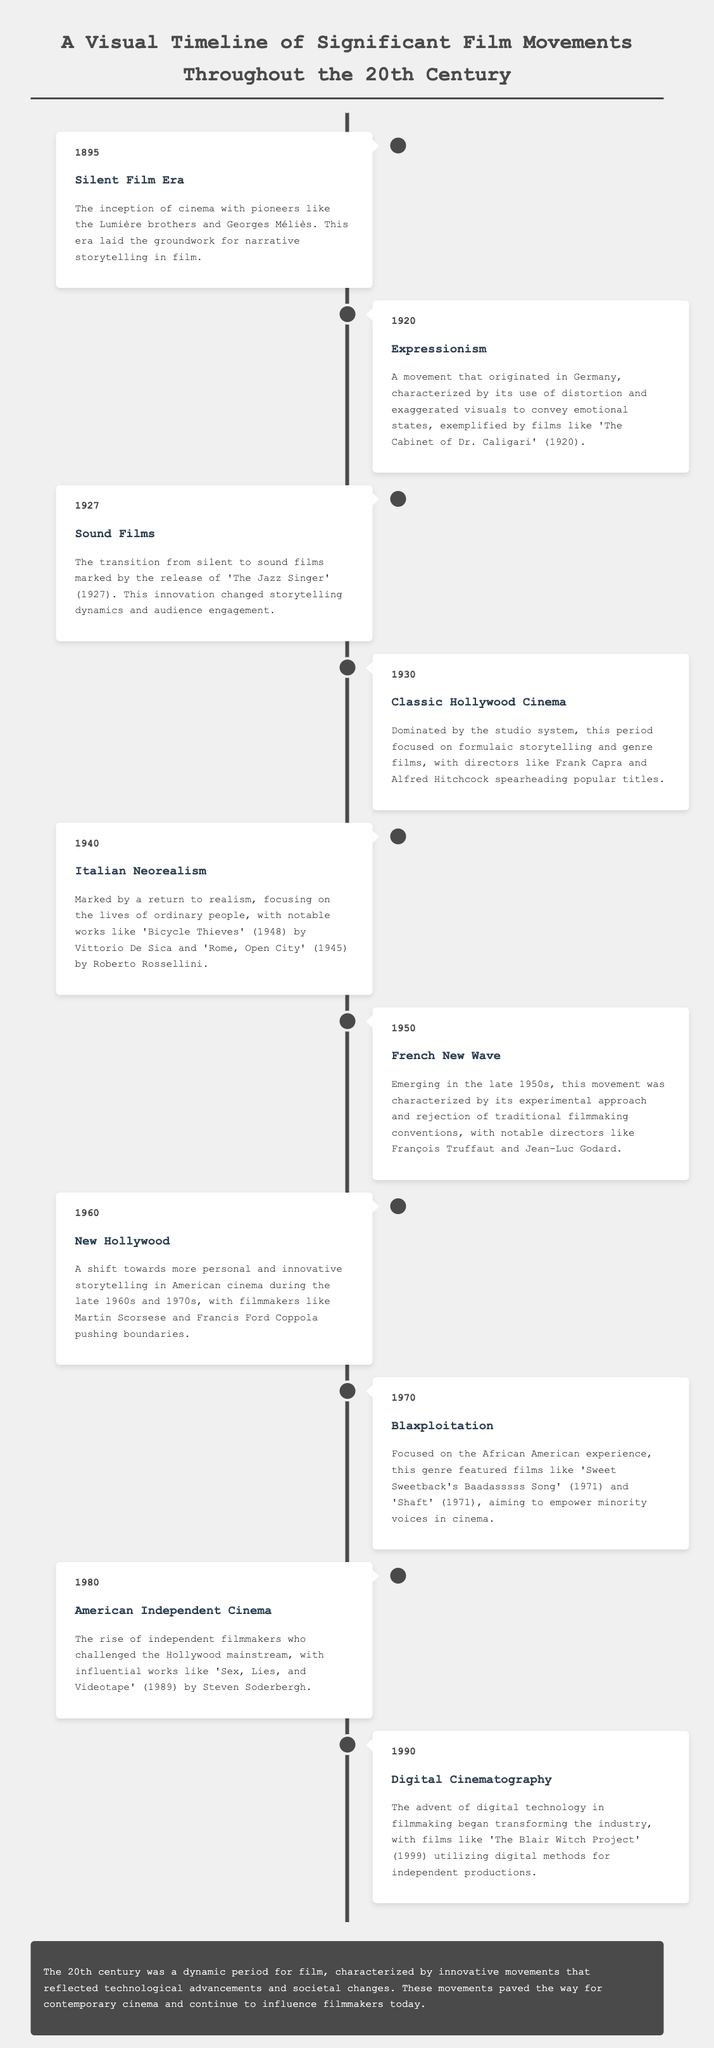What year did the Silent Film Era begin? The document states that the Silent Film Era began in 1895.
Answer: 1895 What movement is characterized by distortion and exaggerated visuals? The document mentions Expressionism as a movement characterized by distortion and exaggerated visuals.
Answer: Expressionism Which film marked the transition to sound films? According to the document, 'The Jazz Singer' (1927) marked the transition to sound films.
Answer: The Jazz Singer What is the defining feature of Italian Neorealism? The document describes Italian Neorealism as focusing on the lives of ordinary people.
Answer: Lives of ordinary people Who were two influential directors from the French New Wave? The document lists François Truffaut and Jean-Luc Godard as notable directors from the French New Wave.
Answer: François Truffaut and Jean-Luc Godard What year is associated with the rise of American Independent Cinema? The document states that the rise of American Independent Cinema occurred in the 1980s.
Answer: 1980 What significant change did digital cinematography bring to filmmaking? The document indicates that digital cinematography began transforming the industry by utilizing digital methods.
Answer: Transforming the industry What does the conclusion highlight about the 20th century for film? The conclusion mentions that the 20th century was characterized by innovative movements and societal changes.
Answer: Innovative movements and societal changes 